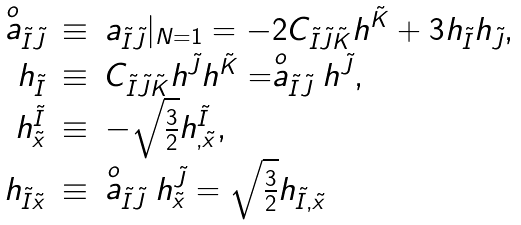Convert formula to latex. <formula><loc_0><loc_0><loc_500><loc_500>\begin{array} { r c l } \stackrel { o } { a } _ { \tilde { I } \tilde { J } } & \equiv & a _ { \tilde { I } \tilde { J } } | _ { N = 1 } = - 2 C _ { \tilde { I } \tilde { J } \tilde { K } } h ^ { \tilde { K } } + 3 h _ { \tilde { I } } h _ { \tilde { J } } , \\ h _ { \tilde { I } } & \equiv & C _ { \tilde { I } \tilde { J } \tilde { K } } h ^ { \tilde { J } } h ^ { \tilde { K } } = \stackrel { o } { a } _ { \tilde { I } \tilde { J } } h ^ { \tilde { J } } , \\ h ^ { \tilde { I } } _ { \tilde { x } } & \equiv & - \sqrt { \frac { 3 } { 2 } } h ^ { \tilde { I } } _ { , \tilde { x } } , \\ h _ { \tilde { I } \tilde { x } } & \equiv & \stackrel { o } { a } _ { \tilde { I } \tilde { J } } h ^ { \tilde { J } } _ { \tilde { x } } = \sqrt { \frac { 3 } { 2 } } h _ { \tilde { I } , \tilde { x } } \end{array}</formula> 